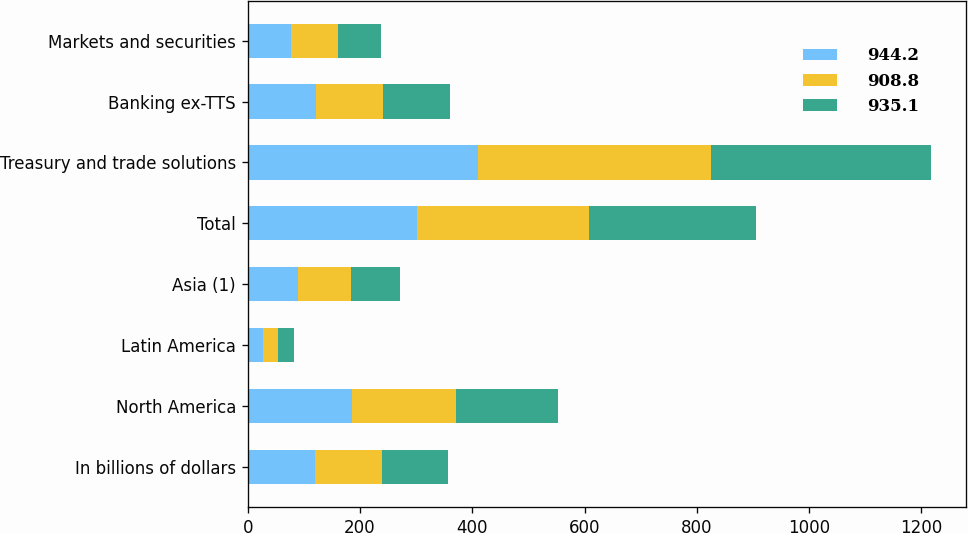<chart> <loc_0><loc_0><loc_500><loc_500><stacked_bar_chart><ecel><fcel>In billions of dollars<fcel>North America<fcel>Latin America<fcel>Asia (1)<fcel>Total<fcel>Treasury and trade solutions<fcel>Banking ex-TTS<fcel>Markets and securities<nl><fcel>944.2<fcel>119.1<fcel>185<fcel>26.4<fcel>89.9<fcel>301.3<fcel>410.6<fcel>122.3<fcel>77.5<nl><fcel>908.8<fcel>119.1<fcel>185.6<fcel>27.4<fcel>93.6<fcel>306.6<fcel>415<fcel>118.9<fcel>83.3<nl><fcel>935.1<fcel>119.1<fcel>181.6<fcel>28.7<fcel>87.6<fcel>297.9<fcel>392<fcel>119.1<fcel>76.6<nl></chart> 